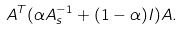Convert formula to latex. <formula><loc_0><loc_0><loc_500><loc_500>A ^ { T } ( \alpha A _ { s } ^ { - 1 } + ( 1 - \alpha ) I ) A .</formula> 